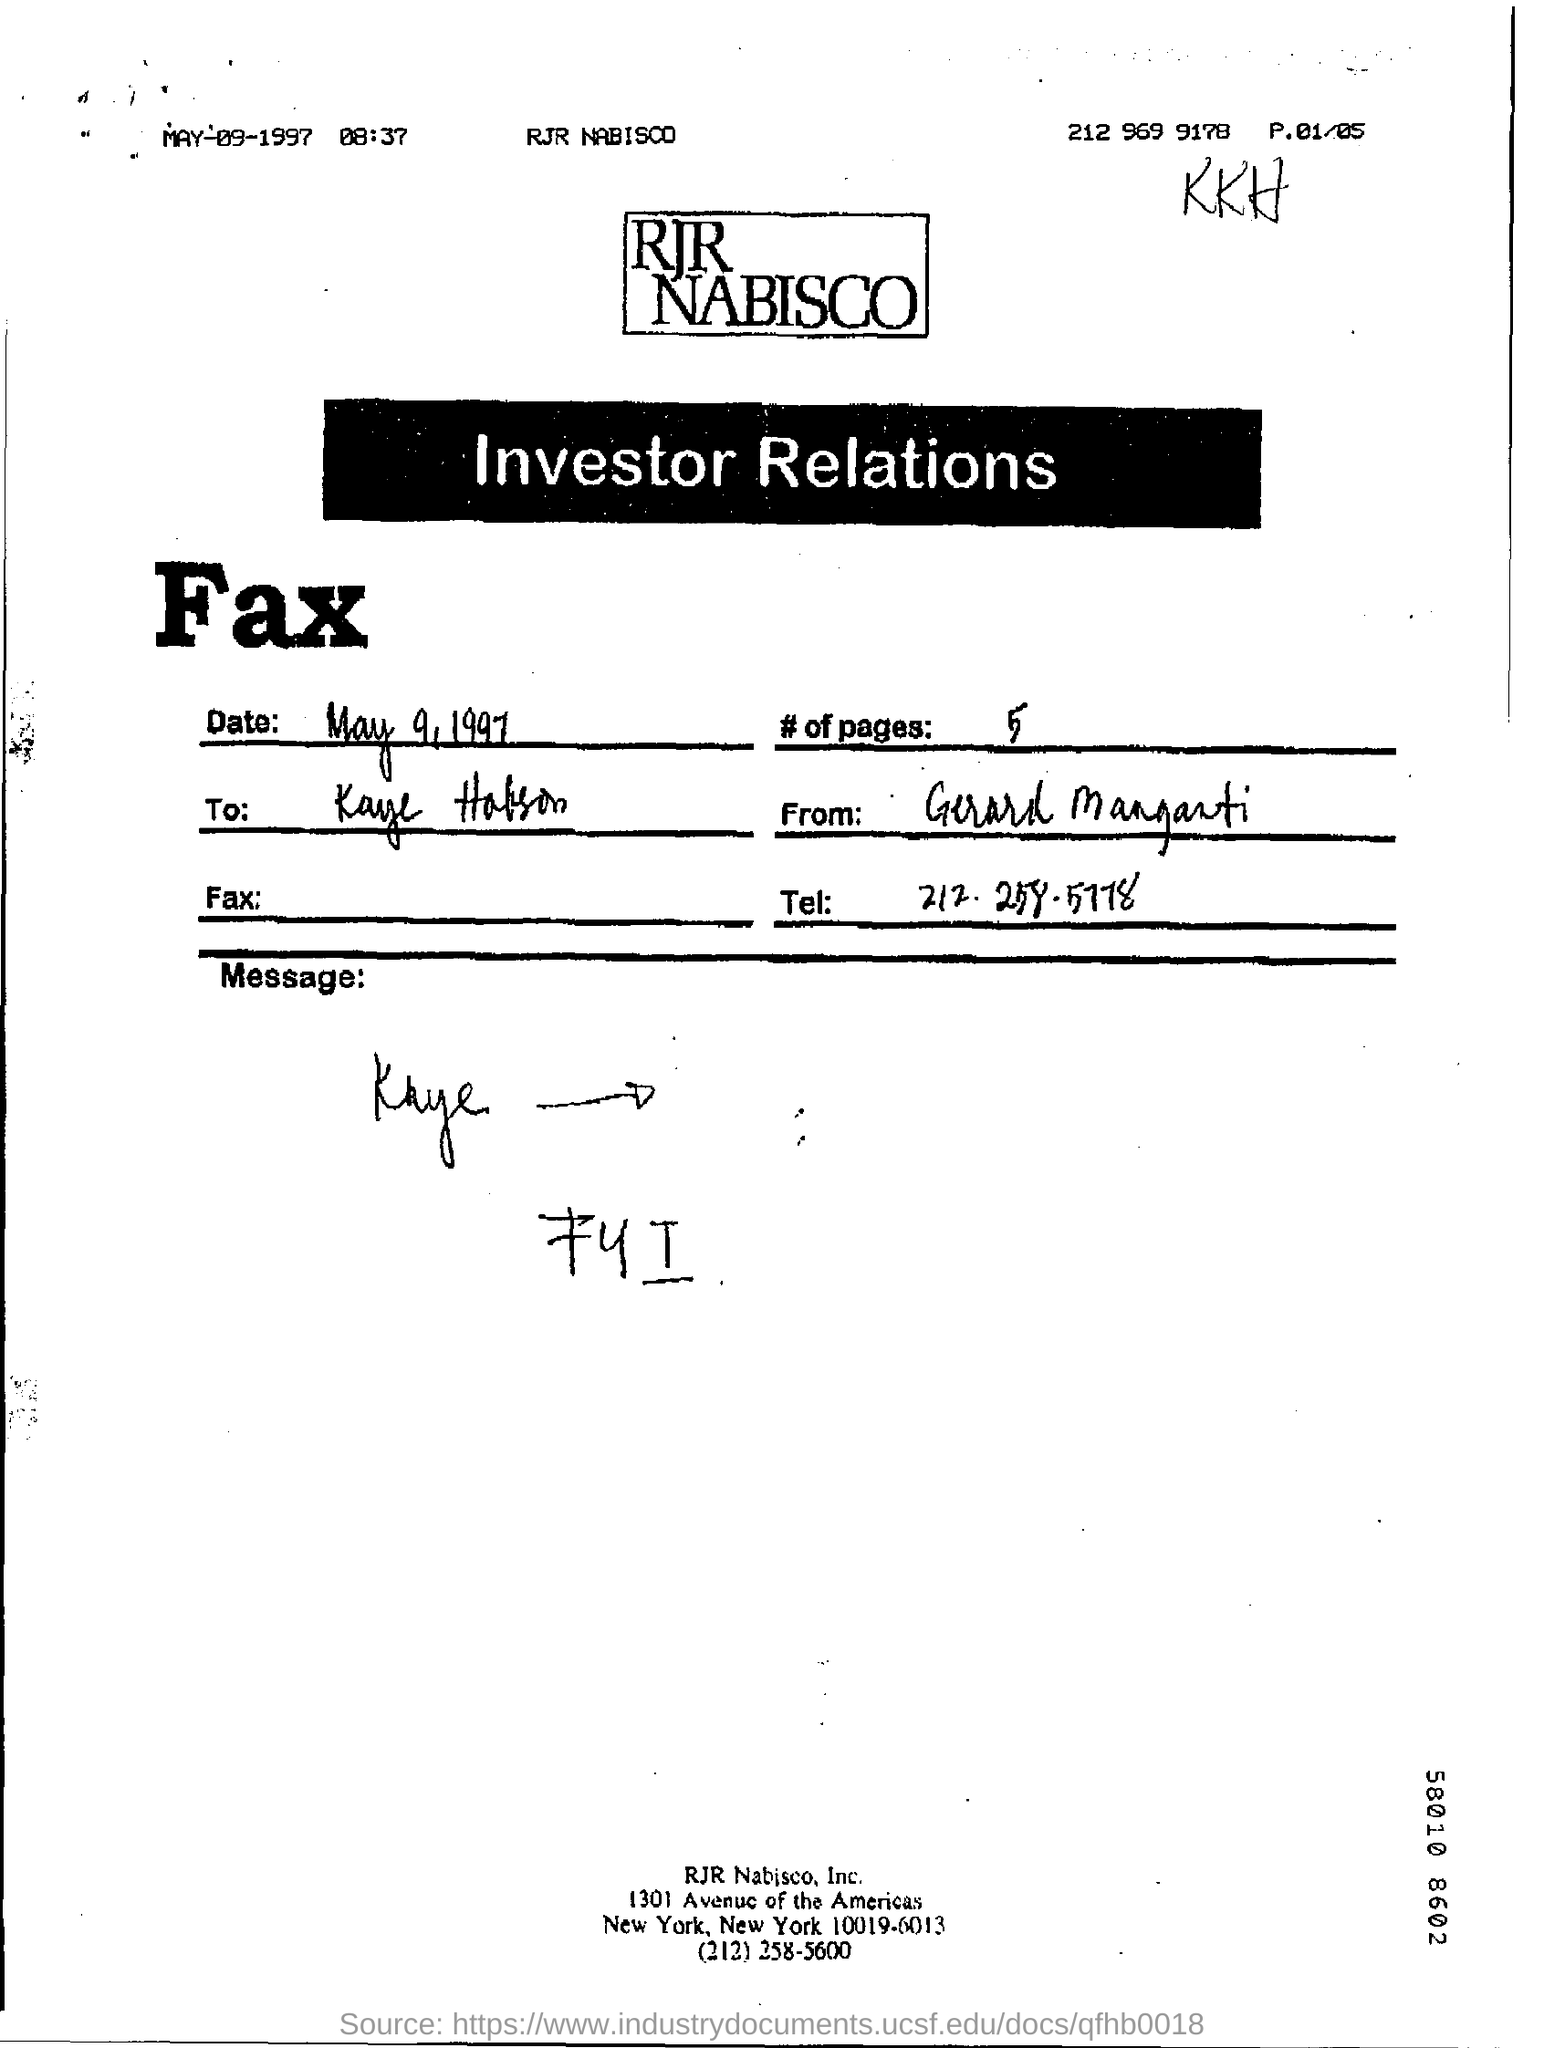What is the date of fax transmission?
Your answer should be very brief. May 9, 1997. What is the no of pages in the fax?
Make the answer very short. 5. What is the tel. no. mentioned in the fax?
Make the answer very short. 212-258-5778. 